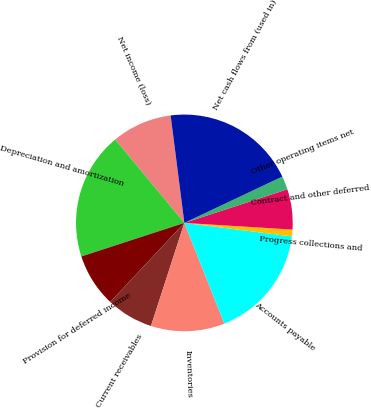<chart> <loc_0><loc_0><loc_500><loc_500><pie_chart><fcel>Net income (loss)<fcel>Depreciation and amortization<fcel>Provision for deferred income<fcel>Current receivables<fcel>Inventories<fcel>Accounts payable<fcel>Progress collections and<fcel>Contract and other deferred<fcel>Other operating items net<fcel>Net cash flows from (used in)<nl><fcel>9.0%<fcel>18.99%<fcel>8.0%<fcel>7.0%<fcel>11.0%<fcel>16.99%<fcel>1.01%<fcel>6.0%<fcel>2.01%<fcel>19.99%<nl></chart> 